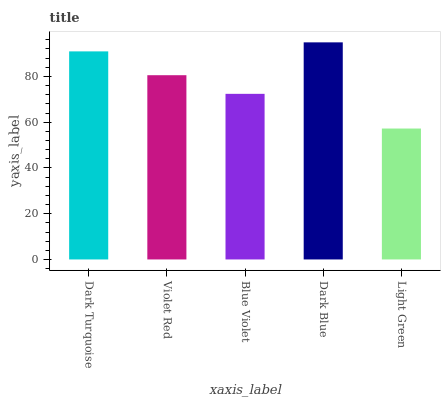Is Light Green the minimum?
Answer yes or no. Yes. Is Dark Blue the maximum?
Answer yes or no. Yes. Is Violet Red the minimum?
Answer yes or no. No. Is Violet Red the maximum?
Answer yes or no. No. Is Dark Turquoise greater than Violet Red?
Answer yes or no. Yes. Is Violet Red less than Dark Turquoise?
Answer yes or no. Yes. Is Violet Red greater than Dark Turquoise?
Answer yes or no. No. Is Dark Turquoise less than Violet Red?
Answer yes or no. No. Is Violet Red the high median?
Answer yes or no. Yes. Is Violet Red the low median?
Answer yes or no. Yes. Is Dark Blue the high median?
Answer yes or no. No. Is Dark Blue the low median?
Answer yes or no. No. 